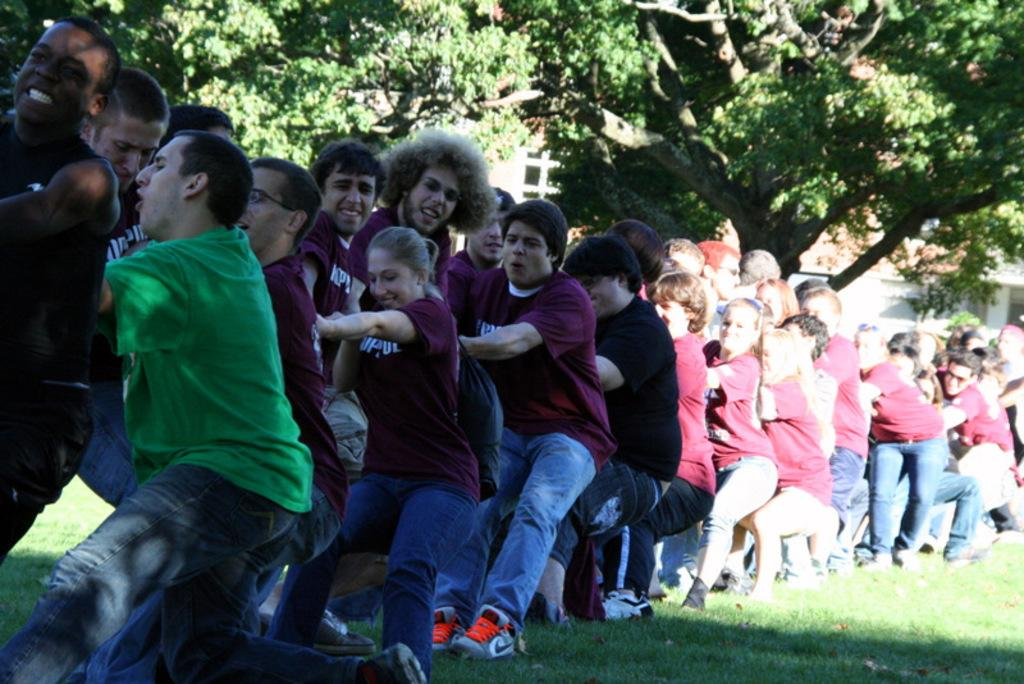What are the people in the image doing? The people in the image are standing on the ground. What can be seen in the distance behind the people? There are buildings and trees in the background of the image. What type of tax is being discussed by the people in the image? There is no indication in the image that the people are discussing any type of tax. 